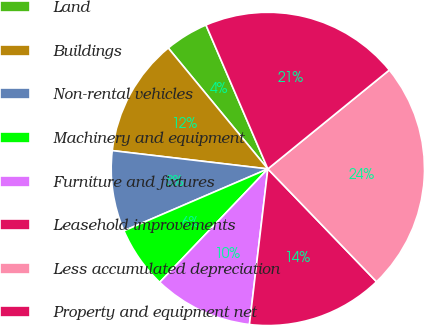Convert chart to OTSL. <chart><loc_0><loc_0><loc_500><loc_500><pie_chart><fcel>Land<fcel>Buildings<fcel>Non-rental vehicles<fcel>Machinery and equipment<fcel>Furniture and fixtures<fcel>Leasehold improvements<fcel>Less accumulated depreciation<fcel>Property and equipment net<nl><fcel>4.5%<fcel>12.17%<fcel>8.33%<fcel>6.41%<fcel>10.25%<fcel>14.08%<fcel>23.67%<fcel>20.59%<nl></chart> 